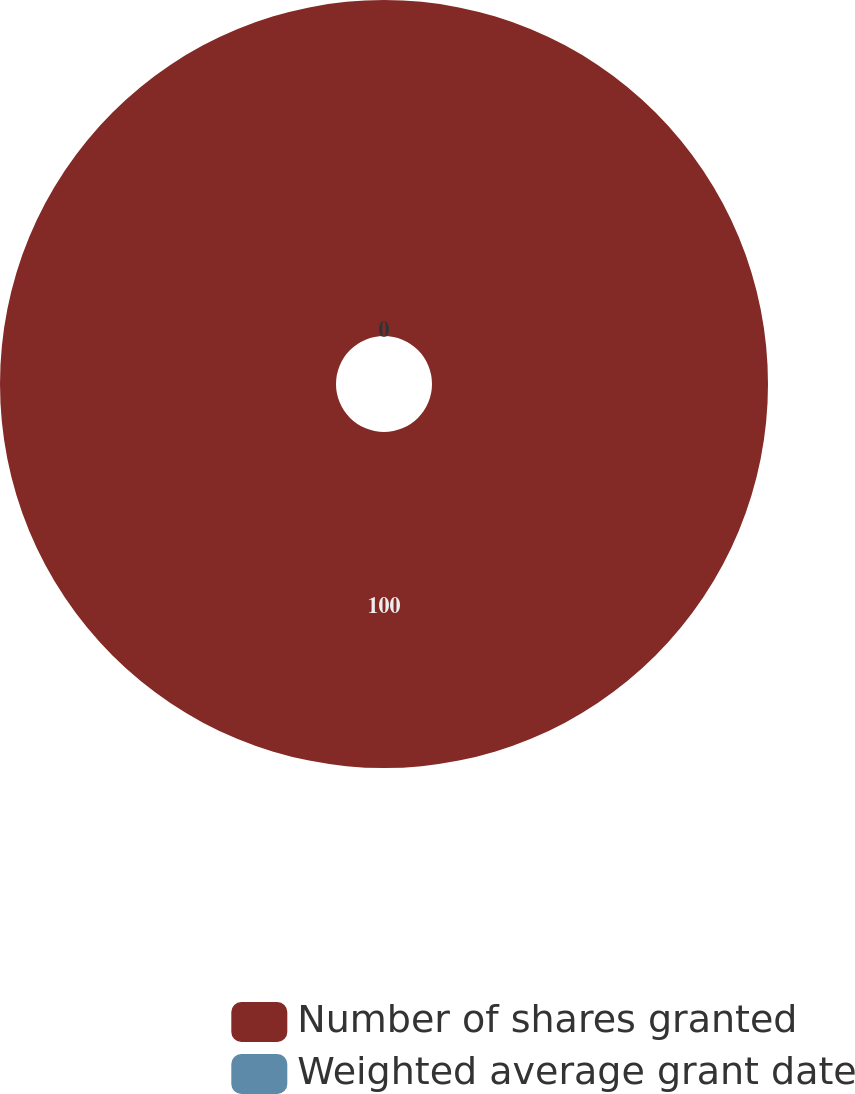Convert chart. <chart><loc_0><loc_0><loc_500><loc_500><pie_chart><fcel>Number of shares granted<fcel>Weighted average grant date<nl><fcel>100.0%<fcel>0.0%<nl></chart> 